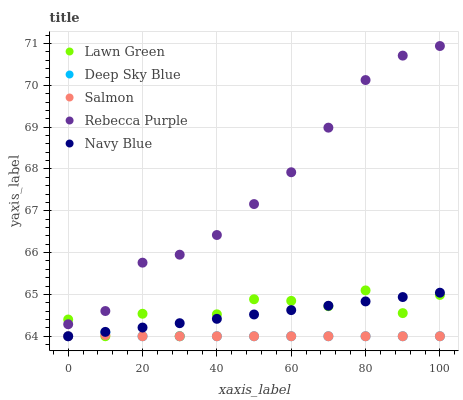Does Salmon have the minimum area under the curve?
Answer yes or no. Yes. Does Rebecca Purple have the maximum area under the curve?
Answer yes or no. Yes. Does Rebecca Purple have the minimum area under the curve?
Answer yes or no. No. Does Salmon have the maximum area under the curve?
Answer yes or no. No. Is Navy Blue the smoothest?
Answer yes or no. Yes. Is Lawn Green the roughest?
Answer yes or no. Yes. Is Salmon the smoothest?
Answer yes or no. No. Is Salmon the roughest?
Answer yes or no. No. Does Lawn Green have the lowest value?
Answer yes or no. Yes. Does Rebecca Purple have the lowest value?
Answer yes or no. No. Does Rebecca Purple have the highest value?
Answer yes or no. Yes. Does Salmon have the highest value?
Answer yes or no. No. Is Salmon less than Rebecca Purple?
Answer yes or no. Yes. Is Rebecca Purple greater than Salmon?
Answer yes or no. Yes. Does Lawn Green intersect Navy Blue?
Answer yes or no. Yes. Is Lawn Green less than Navy Blue?
Answer yes or no. No. Is Lawn Green greater than Navy Blue?
Answer yes or no. No. Does Salmon intersect Rebecca Purple?
Answer yes or no. No. 